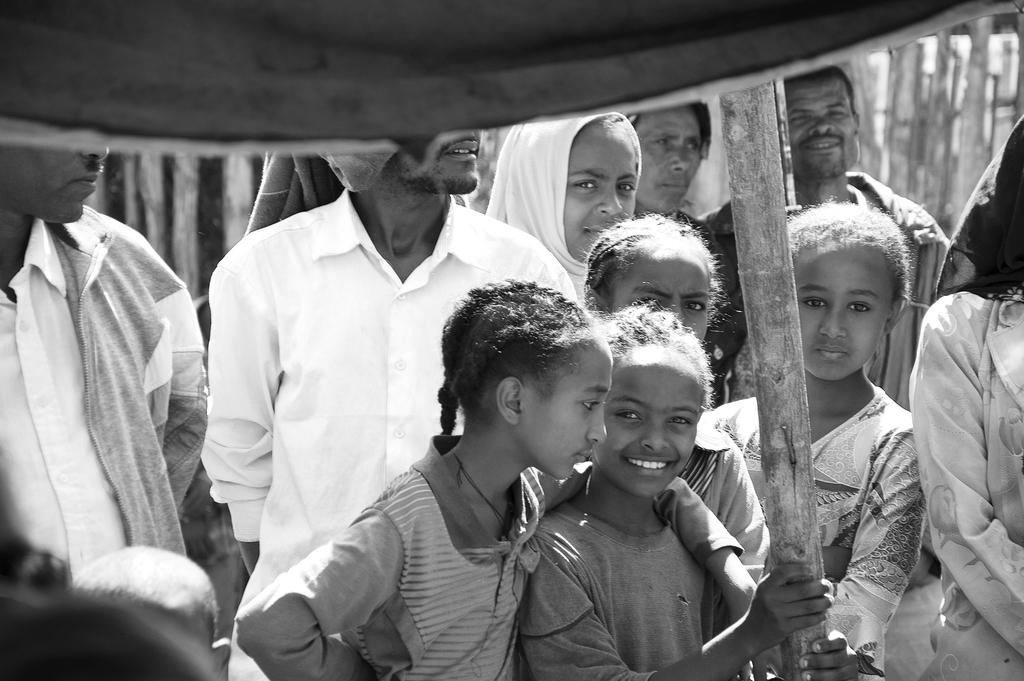What is the main subject of the image? The main subject of the image is a group of girls. How are the girls in the image feeling? The girls are smiling, which suggests they are happy or enjoying themselves. What are the girls doing in the image? The girls are looking at the camera, which suggests they are posing for a photo or interacting with the photographer. Can you describe the background of the image? There are other persons visible in the background of the image. What type of mitten is the girl on the left wearing in the image? There is no mitten visible in the image; the girls are not wearing any gloves or mittens. Can you describe the feathers on the girl in the middle's hat in the image? There is no hat with feathers present in the image; the girls are not wearing any hats or headwear with feathers. 